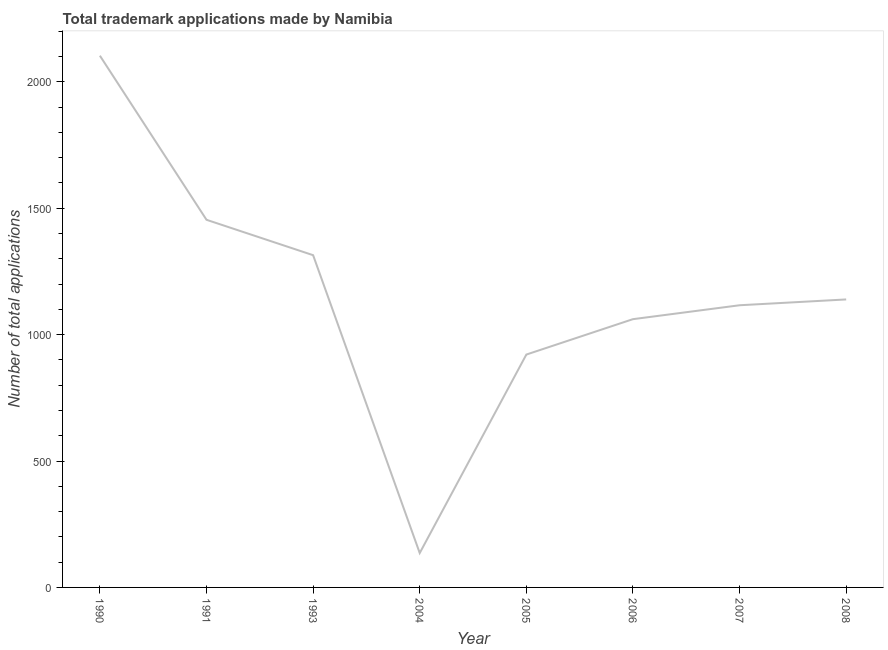What is the number of trademark applications in 2008?
Provide a short and direct response. 1139. Across all years, what is the maximum number of trademark applications?
Offer a terse response. 2103. Across all years, what is the minimum number of trademark applications?
Make the answer very short. 136. In which year was the number of trademark applications minimum?
Ensure brevity in your answer.  2004. What is the sum of the number of trademark applications?
Make the answer very short. 9244. What is the difference between the number of trademark applications in 2005 and 2008?
Your answer should be compact. -218. What is the average number of trademark applications per year?
Your answer should be very brief. 1155.5. What is the median number of trademark applications?
Keep it short and to the point. 1127.5. In how many years, is the number of trademark applications greater than 100 ?
Your answer should be very brief. 8. What is the ratio of the number of trademark applications in 2006 to that in 2007?
Provide a succinct answer. 0.95. What is the difference between the highest and the second highest number of trademark applications?
Offer a very short reply. 649. What is the difference between the highest and the lowest number of trademark applications?
Provide a short and direct response. 1967. How many lines are there?
Make the answer very short. 1. What is the difference between two consecutive major ticks on the Y-axis?
Ensure brevity in your answer.  500. Are the values on the major ticks of Y-axis written in scientific E-notation?
Your response must be concise. No. Does the graph contain any zero values?
Give a very brief answer. No. What is the title of the graph?
Offer a terse response. Total trademark applications made by Namibia. What is the label or title of the Y-axis?
Your answer should be very brief. Number of total applications. What is the Number of total applications in 1990?
Provide a succinct answer. 2103. What is the Number of total applications in 1991?
Your answer should be very brief. 1454. What is the Number of total applications in 1993?
Your answer should be compact. 1314. What is the Number of total applications in 2004?
Provide a short and direct response. 136. What is the Number of total applications in 2005?
Give a very brief answer. 921. What is the Number of total applications of 2006?
Offer a terse response. 1061. What is the Number of total applications of 2007?
Keep it short and to the point. 1116. What is the Number of total applications of 2008?
Offer a terse response. 1139. What is the difference between the Number of total applications in 1990 and 1991?
Make the answer very short. 649. What is the difference between the Number of total applications in 1990 and 1993?
Provide a short and direct response. 789. What is the difference between the Number of total applications in 1990 and 2004?
Your response must be concise. 1967. What is the difference between the Number of total applications in 1990 and 2005?
Your answer should be very brief. 1182. What is the difference between the Number of total applications in 1990 and 2006?
Make the answer very short. 1042. What is the difference between the Number of total applications in 1990 and 2007?
Offer a very short reply. 987. What is the difference between the Number of total applications in 1990 and 2008?
Your answer should be compact. 964. What is the difference between the Number of total applications in 1991 and 1993?
Keep it short and to the point. 140. What is the difference between the Number of total applications in 1991 and 2004?
Your answer should be compact. 1318. What is the difference between the Number of total applications in 1991 and 2005?
Provide a short and direct response. 533. What is the difference between the Number of total applications in 1991 and 2006?
Give a very brief answer. 393. What is the difference between the Number of total applications in 1991 and 2007?
Provide a short and direct response. 338. What is the difference between the Number of total applications in 1991 and 2008?
Your answer should be very brief. 315. What is the difference between the Number of total applications in 1993 and 2004?
Make the answer very short. 1178. What is the difference between the Number of total applications in 1993 and 2005?
Offer a very short reply. 393. What is the difference between the Number of total applications in 1993 and 2006?
Ensure brevity in your answer.  253. What is the difference between the Number of total applications in 1993 and 2007?
Offer a terse response. 198. What is the difference between the Number of total applications in 1993 and 2008?
Provide a succinct answer. 175. What is the difference between the Number of total applications in 2004 and 2005?
Your answer should be very brief. -785. What is the difference between the Number of total applications in 2004 and 2006?
Offer a very short reply. -925. What is the difference between the Number of total applications in 2004 and 2007?
Keep it short and to the point. -980. What is the difference between the Number of total applications in 2004 and 2008?
Your answer should be compact. -1003. What is the difference between the Number of total applications in 2005 and 2006?
Give a very brief answer. -140. What is the difference between the Number of total applications in 2005 and 2007?
Keep it short and to the point. -195. What is the difference between the Number of total applications in 2005 and 2008?
Your answer should be very brief. -218. What is the difference between the Number of total applications in 2006 and 2007?
Offer a very short reply. -55. What is the difference between the Number of total applications in 2006 and 2008?
Ensure brevity in your answer.  -78. What is the ratio of the Number of total applications in 1990 to that in 1991?
Provide a succinct answer. 1.45. What is the ratio of the Number of total applications in 1990 to that in 2004?
Make the answer very short. 15.46. What is the ratio of the Number of total applications in 1990 to that in 2005?
Keep it short and to the point. 2.28. What is the ratio of the Number of total applications in 1990 to that in 2006?
Offer a terse response. 1.98. What is the ratio of the Number of total applications in 1990 to that in 2007?
Offer a terse response. 1.88. What is the ratio of the Number of total applications in 1990 to that in 2008?
Ensure brevity in your answer.  1.85. What is the ratio of the Number of total applications in 1991 to that in 1993?
Your answer should be compact. 1.11. What is the ratio of the Number of total applications in 1991 to that in 2004?
Your response must be concise. 10.69. What is the ratio of the Number of total applications in 1991 to that in 2005?
Make the answer very short. 1.58. What is the ratio of the Number of total applications in 1991 to that in 2006?
Your response must be concise. 1.37. What is the ratio of the Number of total applications in 1991 to that in 2007?
Your response must be concise. 1.3. What is the ratio of the Number of total applications in 1991 to that in 2008?
Offer a very short reply. 1.28. What is the ratio of the Number of total applications in 1993 to that in 2004?
Provide a succinct answer. 9.66. What is the ratio of the Number of total applications in 1993 to that in 2005?
Offer a very short reply. 1.43. What is the ratio of the Number of total applications in 1993 to that in 2006?
Provide a short and direct response. 1.24. What is the ratio of the Number of total applications in 1993 to that in 2007?
Provide a short and direct response. 1.18. What is the ratio of the Number of total applications in 1993 to that in 2008?
Your answer should be compact. 1.15. What is the ratio of the Number of total applications in 2004 to that in 2005?
Offer a terse response. 0.15. What is the ratio of the Number of total applications in 2004 to that in 2006?
Your answer should be compact. 0.13. What is the ratio of the Number of total applications in 2004 to that in 2007?
Provide a short and direct response. 0.12. What is the ratio of the Number of total applications in 2004 to that in 2008?
Provide a succinct answer. 0.12. What is the ratio of the Number of total applications in 2005 to that in 2006?
Make the answer very short. 0.87. What is the ratio of the Number of total applications in 2005 to that in 2007?
Keep it short and to the point. 0.82. What is the ratio of the Number of total applications in 2005 to that in 2008?
Ensure brevity in your answer.  0.81. What is the ratio of the Number of total applications in 2006 to that in 2007?
Offer a terse response. 0.95. What is the ratio of the Number of total applications in 2006 to that in 2008?
Give a very brief answer. 0.93. What is the ratio of the Number of total applications in 2007 to that in 2008?
Give a very brief answer. 0.98. 